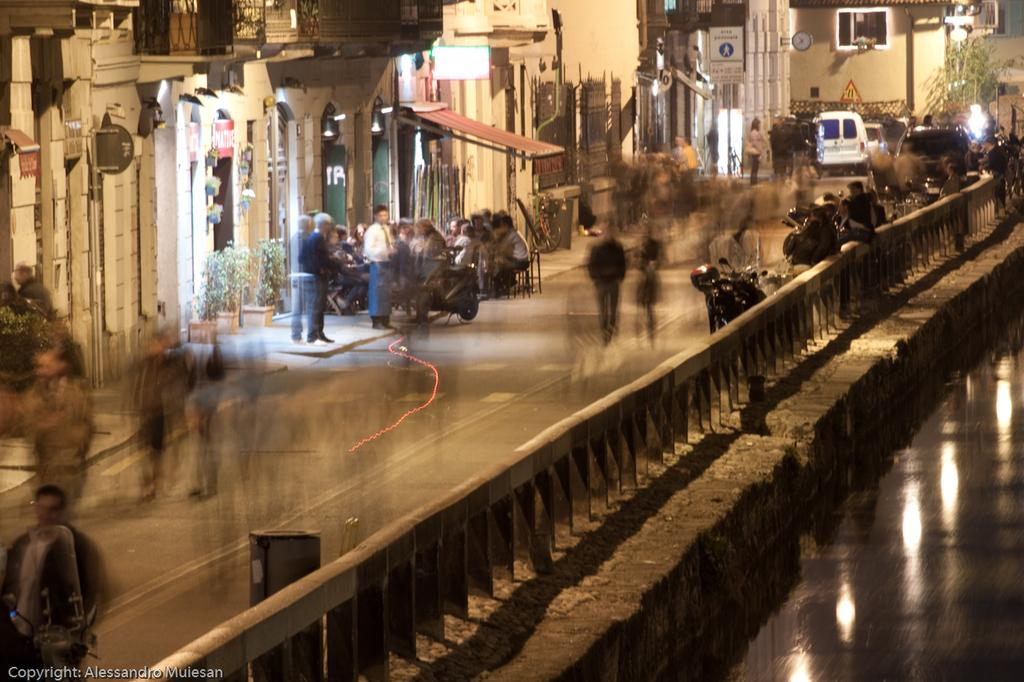What is the primary element visible in the image? There is water in the image. What type of structure can be seen in the image? There is a fence in the image. What type of man-made structures are present in the image? There are buildings in the image. What type of illumination is present in the image? There are lights in the image. Are there any living beings visible in the image? Yes, there are people in the image. What type of signage is present in the image? There is a poster in the image. What type of transportation is present in the image? There is a vehicle in the image. Can you tell me how many ears of corn are visible in the image? There is no corn present in the image. What type of physical activity are the people in the image engaged in? The provided facts do not mention any specific physical activity, so we cannot determine if they are swimming or engaged in any other activity. 